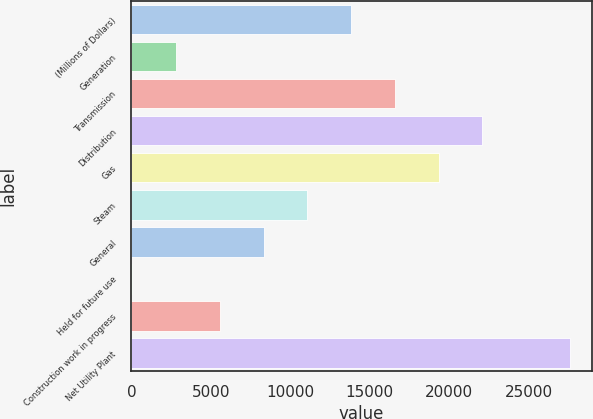<chart> <loc_0><loc_0><loc_500><loc_500><bar_chart><fcel>(Millions of Dollars)<fcel>Generation<fcel>Transmission<fcel>Distribution<fcel>Gas<fcel>Steam<fcel>General<fcel>Held for future use<fcel>Construction work in progress<fcel>Net Utility Plant<nl><fcel>13825<fcel>2817<fcel>16577<fcel>22081<fcel>19329<fcel>11073<fcel>8321<fcel>65<fcel>5569<fcel>27585<nl></chart> 